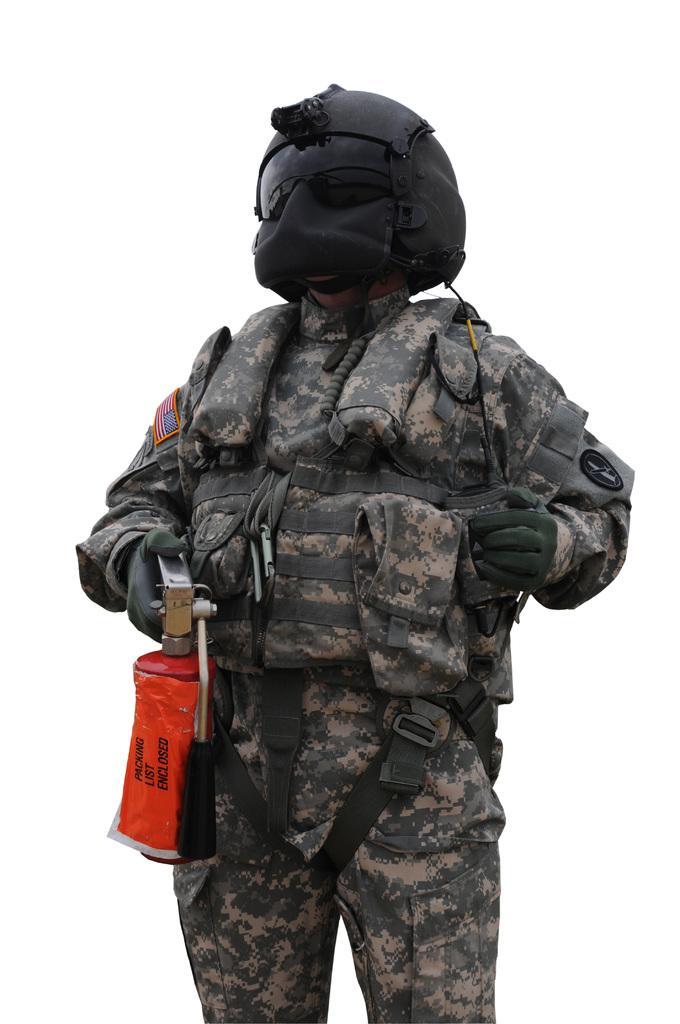Can you describe this image briefly? In the picture we can see a person with a different costume like army clothes and black color helmet with mask to it and holding a gas bottle. 